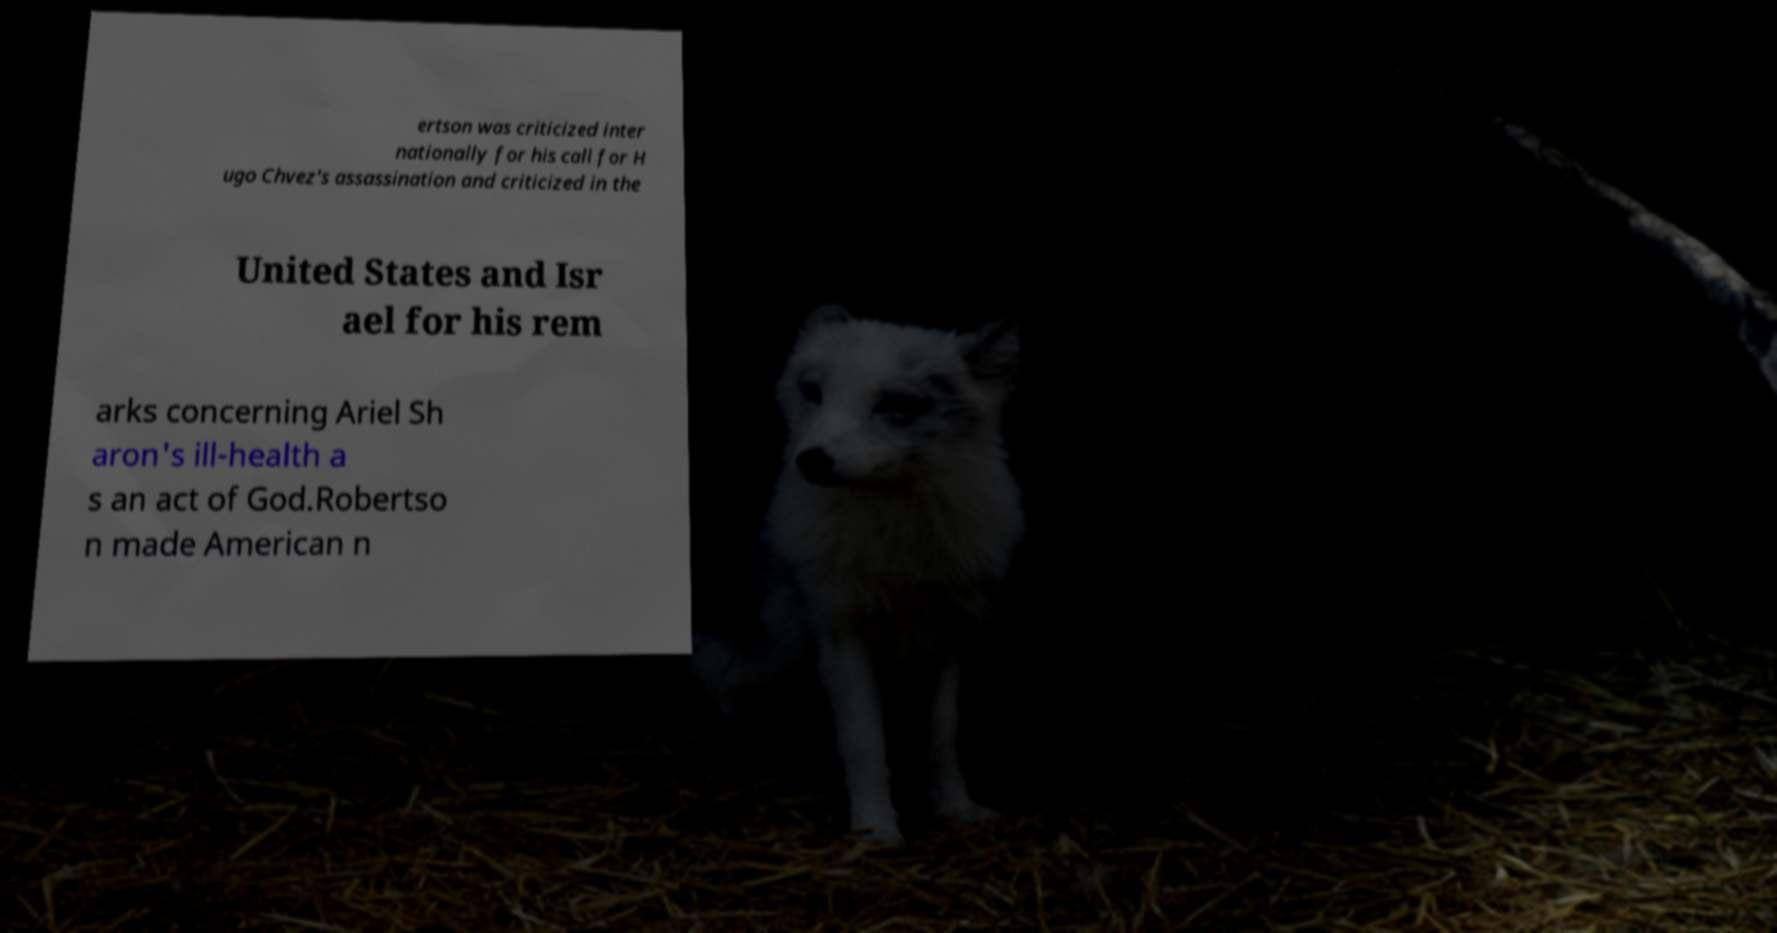Can you read and provide the text displayed in the image?This photo seems to have some interesting text. Can you extract and type it out for me? ertson was criticized inter nationally for his call for H ugo Chvez's assassination and criticized in the United States and Isr ael for his rem arks concerning Ariel Sh aron's ill-health a s an act of God.Robertso n made American n 